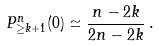<formula> <loc_0><loc_0><loc_500><loc_500>P ^ { n } _ { \geq k + 1 } ( 0 ) \simeq \frac { n - 2 k } { 2 n - 2 k } \, .</formula> 